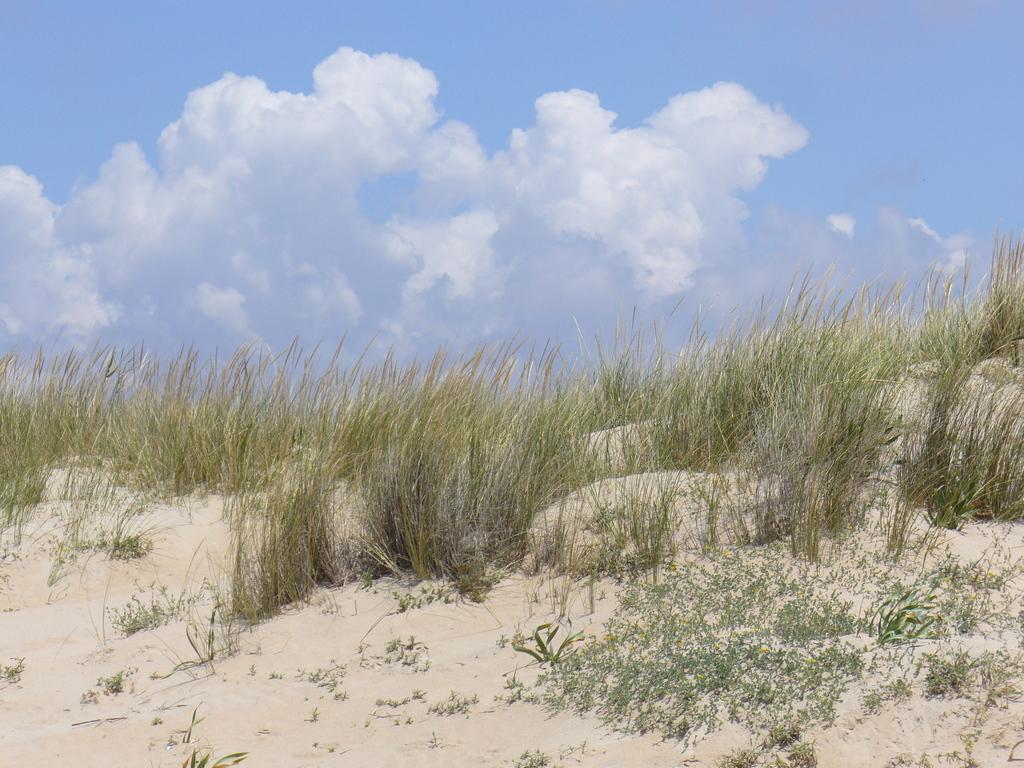Could you give a brief overview of what you see in this image? In the image in the center, we can see the sky, clouds and grass. 